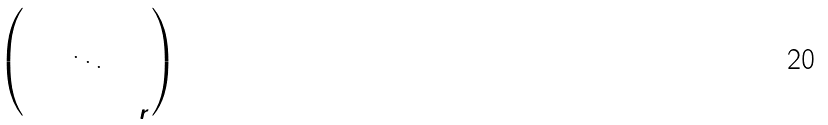<formula> <loc_0><loc_0><loc_500><loc_500>\begin{pmatrix} \Gamma ^ { 0 } _ { 1 } \\ & \ddots \\ & & \Gamma ^ { 0 } _ { r } \end{pmatrix}</formula> 